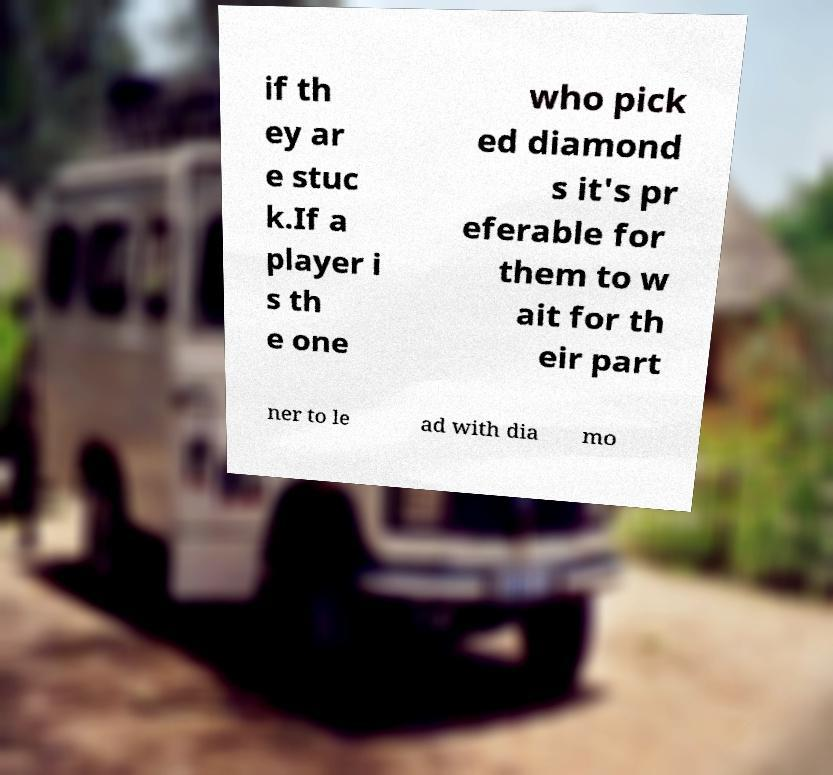Can you read and provide the text displayed in the image?This photo seems to have some interesting text. Can you extract and type it out for me? if th ey ar e stuc k.If a player i s th e one who pick ed diamond s it's pr eferable for them to w ait for th eir part ner to le ad with dia mo 